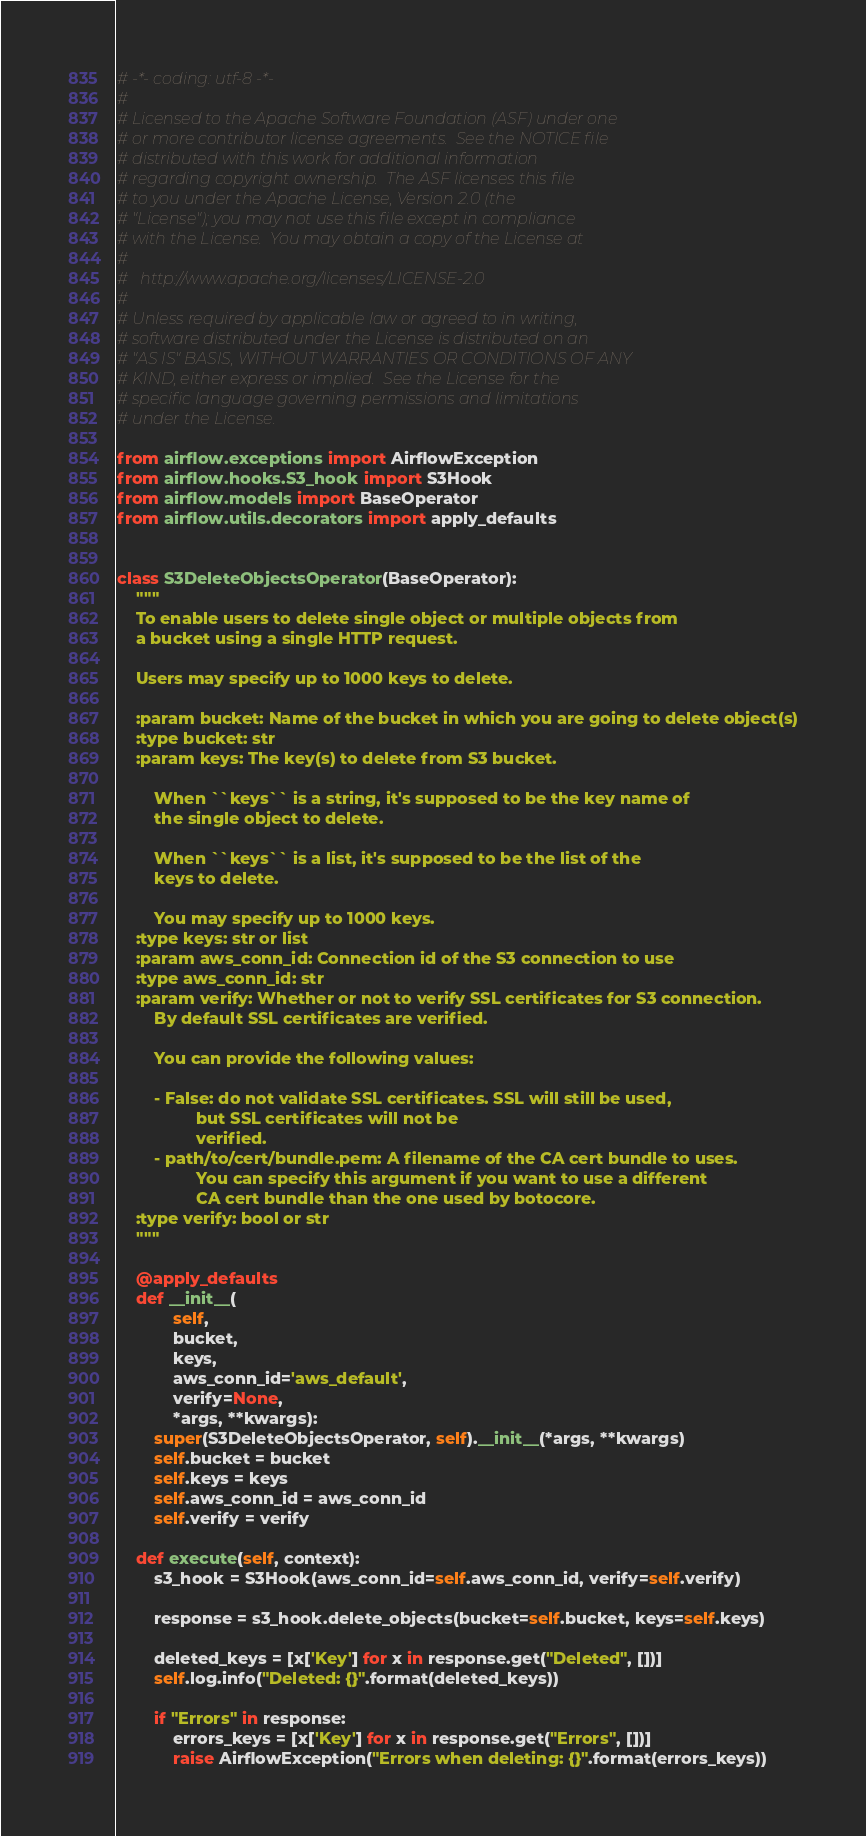Convert code to text. <code><loc_0><loc_0><loc_500><loc_500><_Python_># -*- coding: utf-8 -*-
#
# Licensed to the Apache Software Foundation (ASF) under one
# or more contributor license agreements.  See the NOTICE file
# distributed with this work for additional information
# regarding copyright ownership.  The ASF licenses this file
# to you under the Apache License, Version 2.0 (the
# "License"); you may not use this file except in compliance
# with the License.  You may obtain a copy of the License at
#
#   http://www.apache.org/licenses/LICENSE-2.0
#
# Unless required by applicable law or agreed to in writing,
# software distributed under the License is distributed on an
# "AS IS" BASIS, WITHOUT WARRANTIES OR CONDITIONS OF ANY
# KIND, either express or implied.  See the License for the
# specific language governing permissions and limitations
# under the License.

from airflow.exceptions import AirflowException
from airflow.hooks.S3_hook import S3Hook
from airflow.models import BaseOperator
from airflow.utils.decorators import apply_defaults


class S3DeleteObjectsOperator(BaseOperator):
    """
    To enable users to delete single object or multiple objects from
    a bucket using a single HTTP request.

    Users may specify up to 1000 keys to delete.

    :param bucket: Name of the bucket in which you are going to delete object(s)
    :type bucket: str
    :param keys: The key(s) to delete from S3 bucket.

        When ``keys`` is a string, it's supposed to be the key name of
        the single object to delete.

        When ``keys`` is a list, it's supposed to be the list of the
        keys to delete.

        You may specify up to 1000 keys.
    :type keys: str or list
    :param aws_conn_id: Connection id of the S3 connection to use
    :type aws_conn_id: str
    :param verify: Whether or not to verify SSL certificates for S3 connection.
        By default SSL certificates are verified.

        You can provide the following values:

        - False: do not validate SSL certificates. SSL will still be used,
                 but SSL certificates will not be
                 verified.
        - path/to/cert/bundle.pem: A filename of the CA cert bundle to uses.
                 You can specify this argument if you want to use a different
                 CA cert bundle than the one used by botocore.
    :type verify: bool or str
    """

    @apply_defaults
    def __init__(
            self,
            bucket,
            keys,
            aws_conn_id='aws_default',
            verify=None,
            *args, **kwargs):
        super(S3DeleteObjectsOperator, self).__init__(*args, **kwargs)
        self.bucket = bucket
        self.keys = keys
        self.aws_conn_id = aws_conn_id
        self.verify = verify

    def execute(self, context):
        s3_hook = S3Hook(aws_conn_id=self.aws_conn_id, verify=self.verify)

        response = s3_hook.delete_objects(bucket=self.bucket, keys=self.keys)

        deleted_keys = [x['Key'] for x in response.get("Deleted", [])]
        self.log.info("Deleted: {}".format(deleted_keys))

        if "Errors" in response:
            errors_keys = [x['Key'] for x in response.get("Errors", [])]
            raise AirflowException("Errors when deleting: {}".format(errors_keys))
</code> 